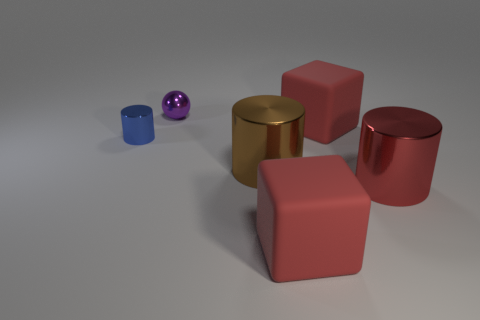Add 3 red cylinders. How many objects exist? 9 Subtract all blocks. How many objects are left? 4 Subtract all big red rubber cubes. Subtract all brown cylinders. How many objects are left? 3 Add 1 blue metal things. How many blue metal things are left? 2 Add 4 tiny gray metal things. How many tiny gray metal things exist? 4 Subtract 0 gray blocks. How many objects are left? 6 